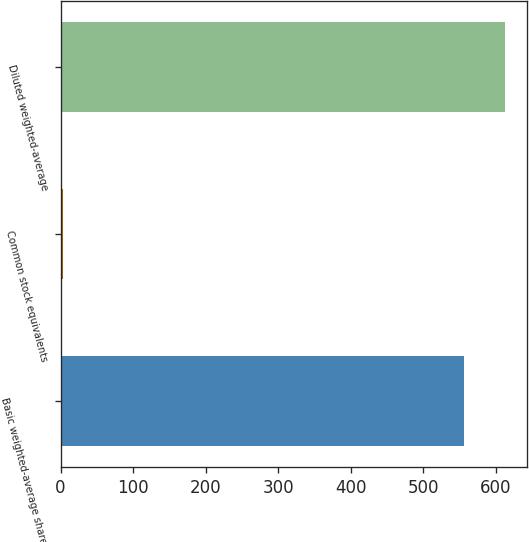Convert chart. <chart><loc_0><loc_0><loc_500><loc_500><bar_chart><fcel>Basic weighted-average shares<fcel>Common stock equivalents<fcel>Diluted weighted-average<nl><fcel>556.6<fcel>3.1<fcel>612.26<nl></chart> 